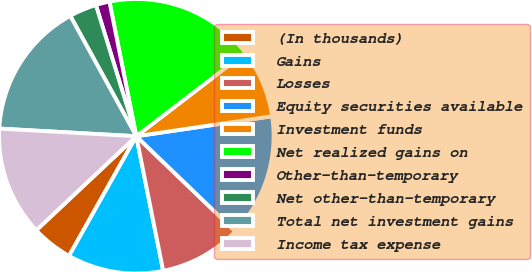<chart> <loc_0><loc_0><loc_500><loc_500><pie_chart><fcel>(In thousands)<fcel>Gains<fcel>Losses<fcel>Equity securities available<fcel>Investment funds<fcel>Net realized gains on<fcel>Other-than-temporary<fcel>Net other-than-temporary<fcel>Total net investment gains<fcel>Income tax expense<nl><fcel>4.84%<fcel>11.29%<fcel>9.68%<fcel>14.51%<fcel>8.07%<fcel>17.74%<fcel>1.62%<fcel>3.23%<fcel>16.13%<fcel>12.9%<nl></chart> 